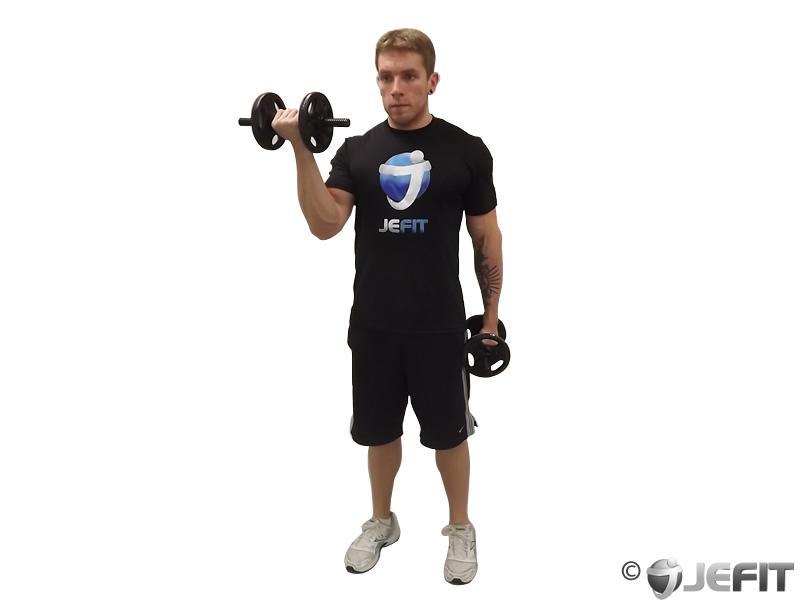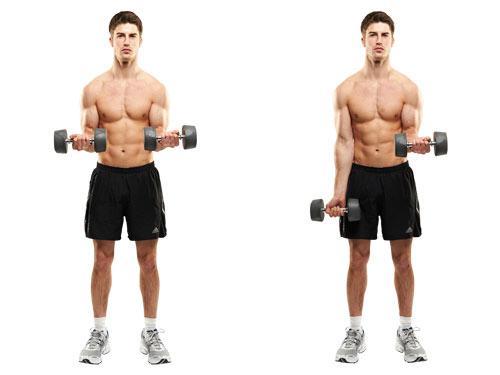The first image is the image on the left, the second image is the image on the right. For the images shown, is this caption "A man wearing blue short is holding dumbells" true? Answer yes or no. No. 